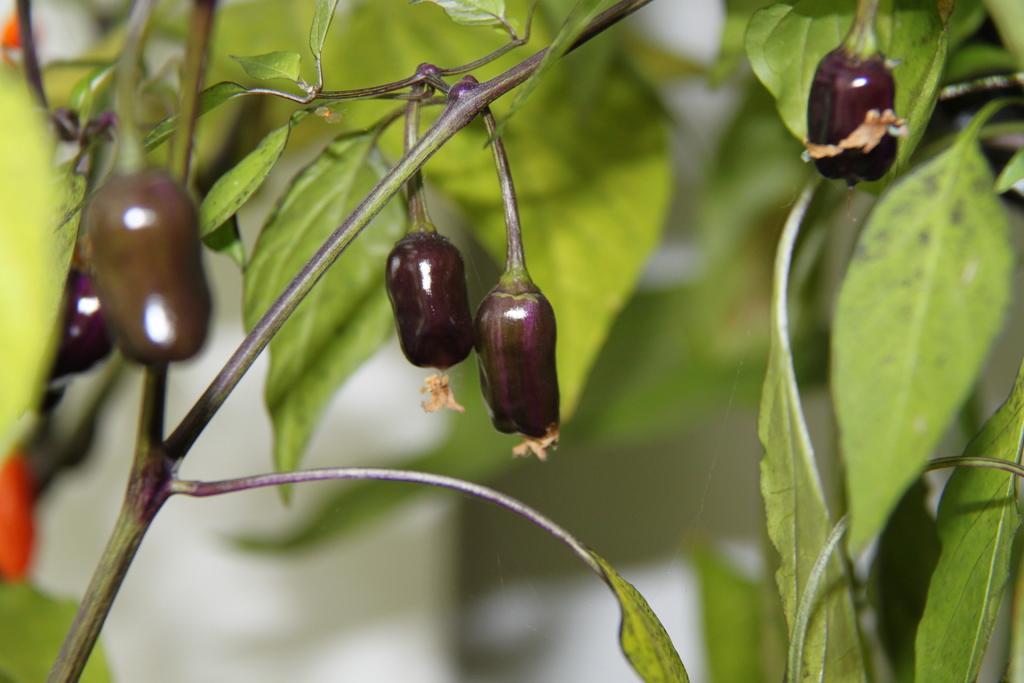Can you describe this image briefly? In this image we can see there is a brinjal plant. 